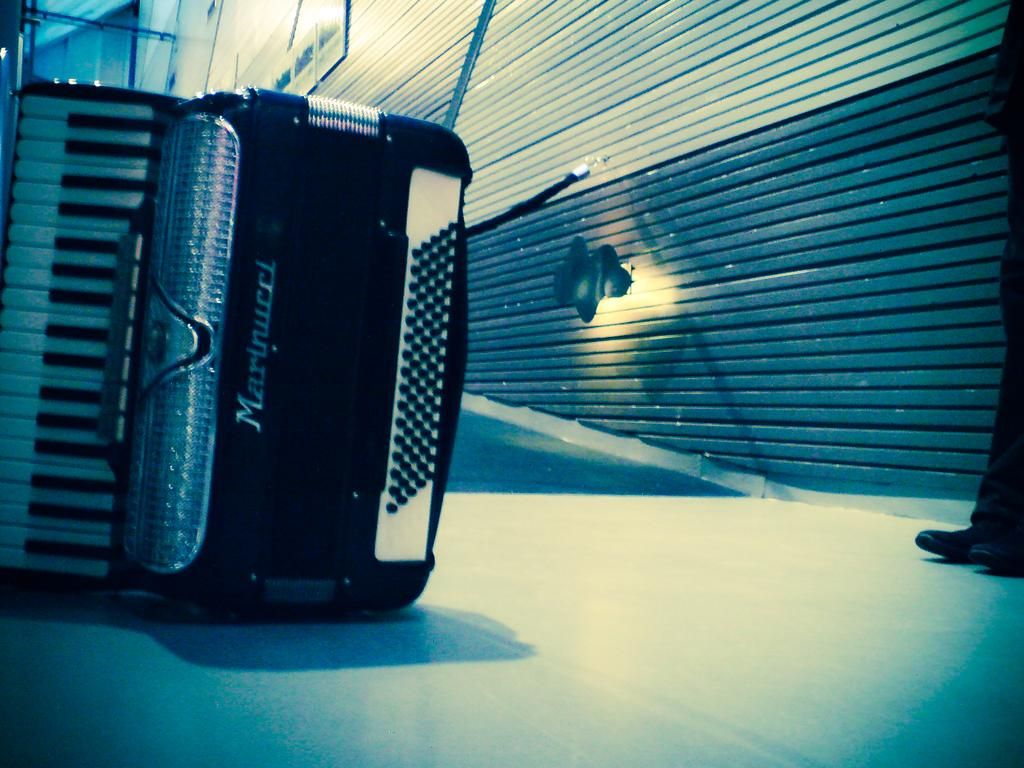What object is on the floor in the image? There is a musical instrument on the floor. Can you describe any part of a person in the image? A person's leg is visible in the image. What type of structure can be seen in the image? There is a wall in the image. What is attached to the wall in the image? There is a light on the wall. What type of steam can be seen coming from the musical instrument in the image? There is no steam present in the image; it features a musical instrument on the floor and a person's leg, a wall, and a light. 